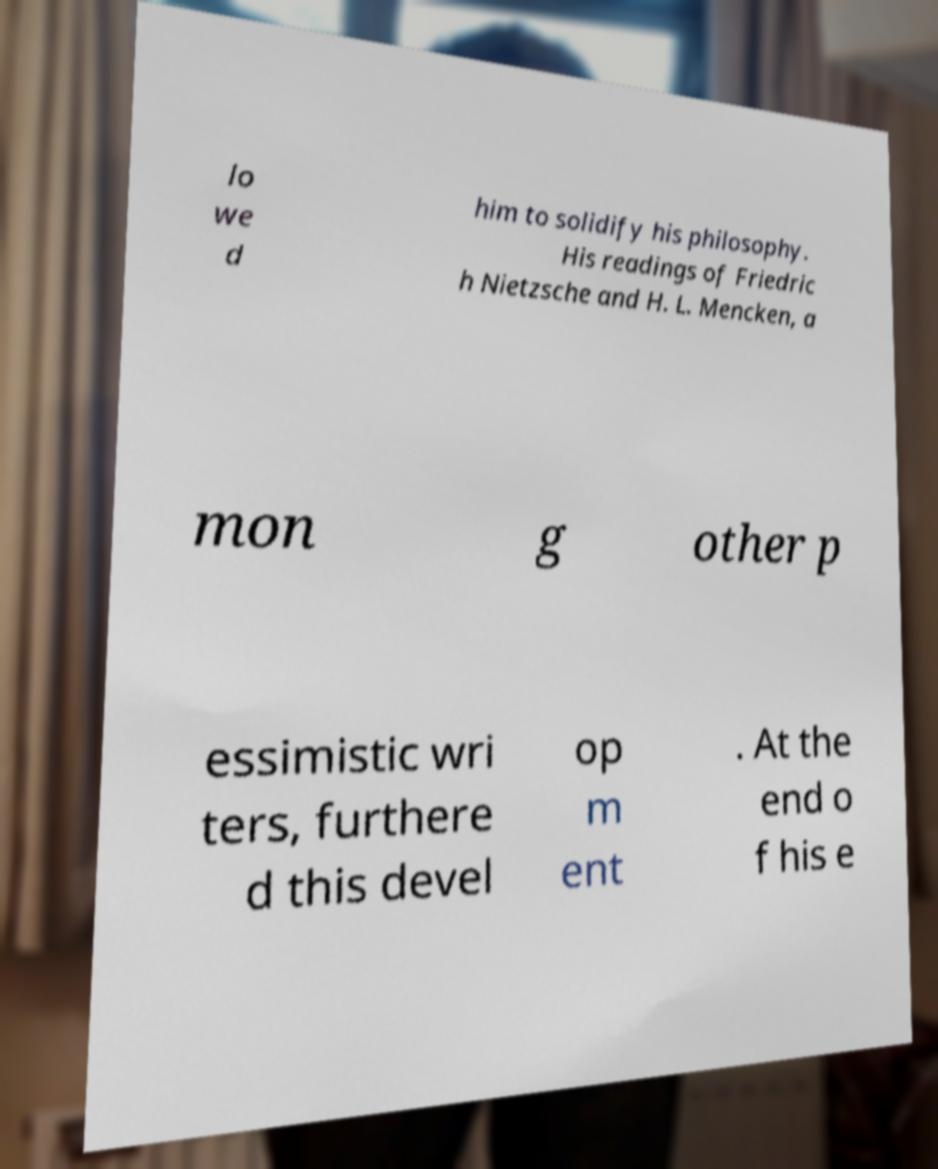Please identify and transcribe the text found in this image. lo we d him to solidify his philosophy. His readings of Friedric h Nietzsche and H. L. Mencken, a mon g other p essimistic wri ters, furthere d this devel op m ent . At the end o f his e 